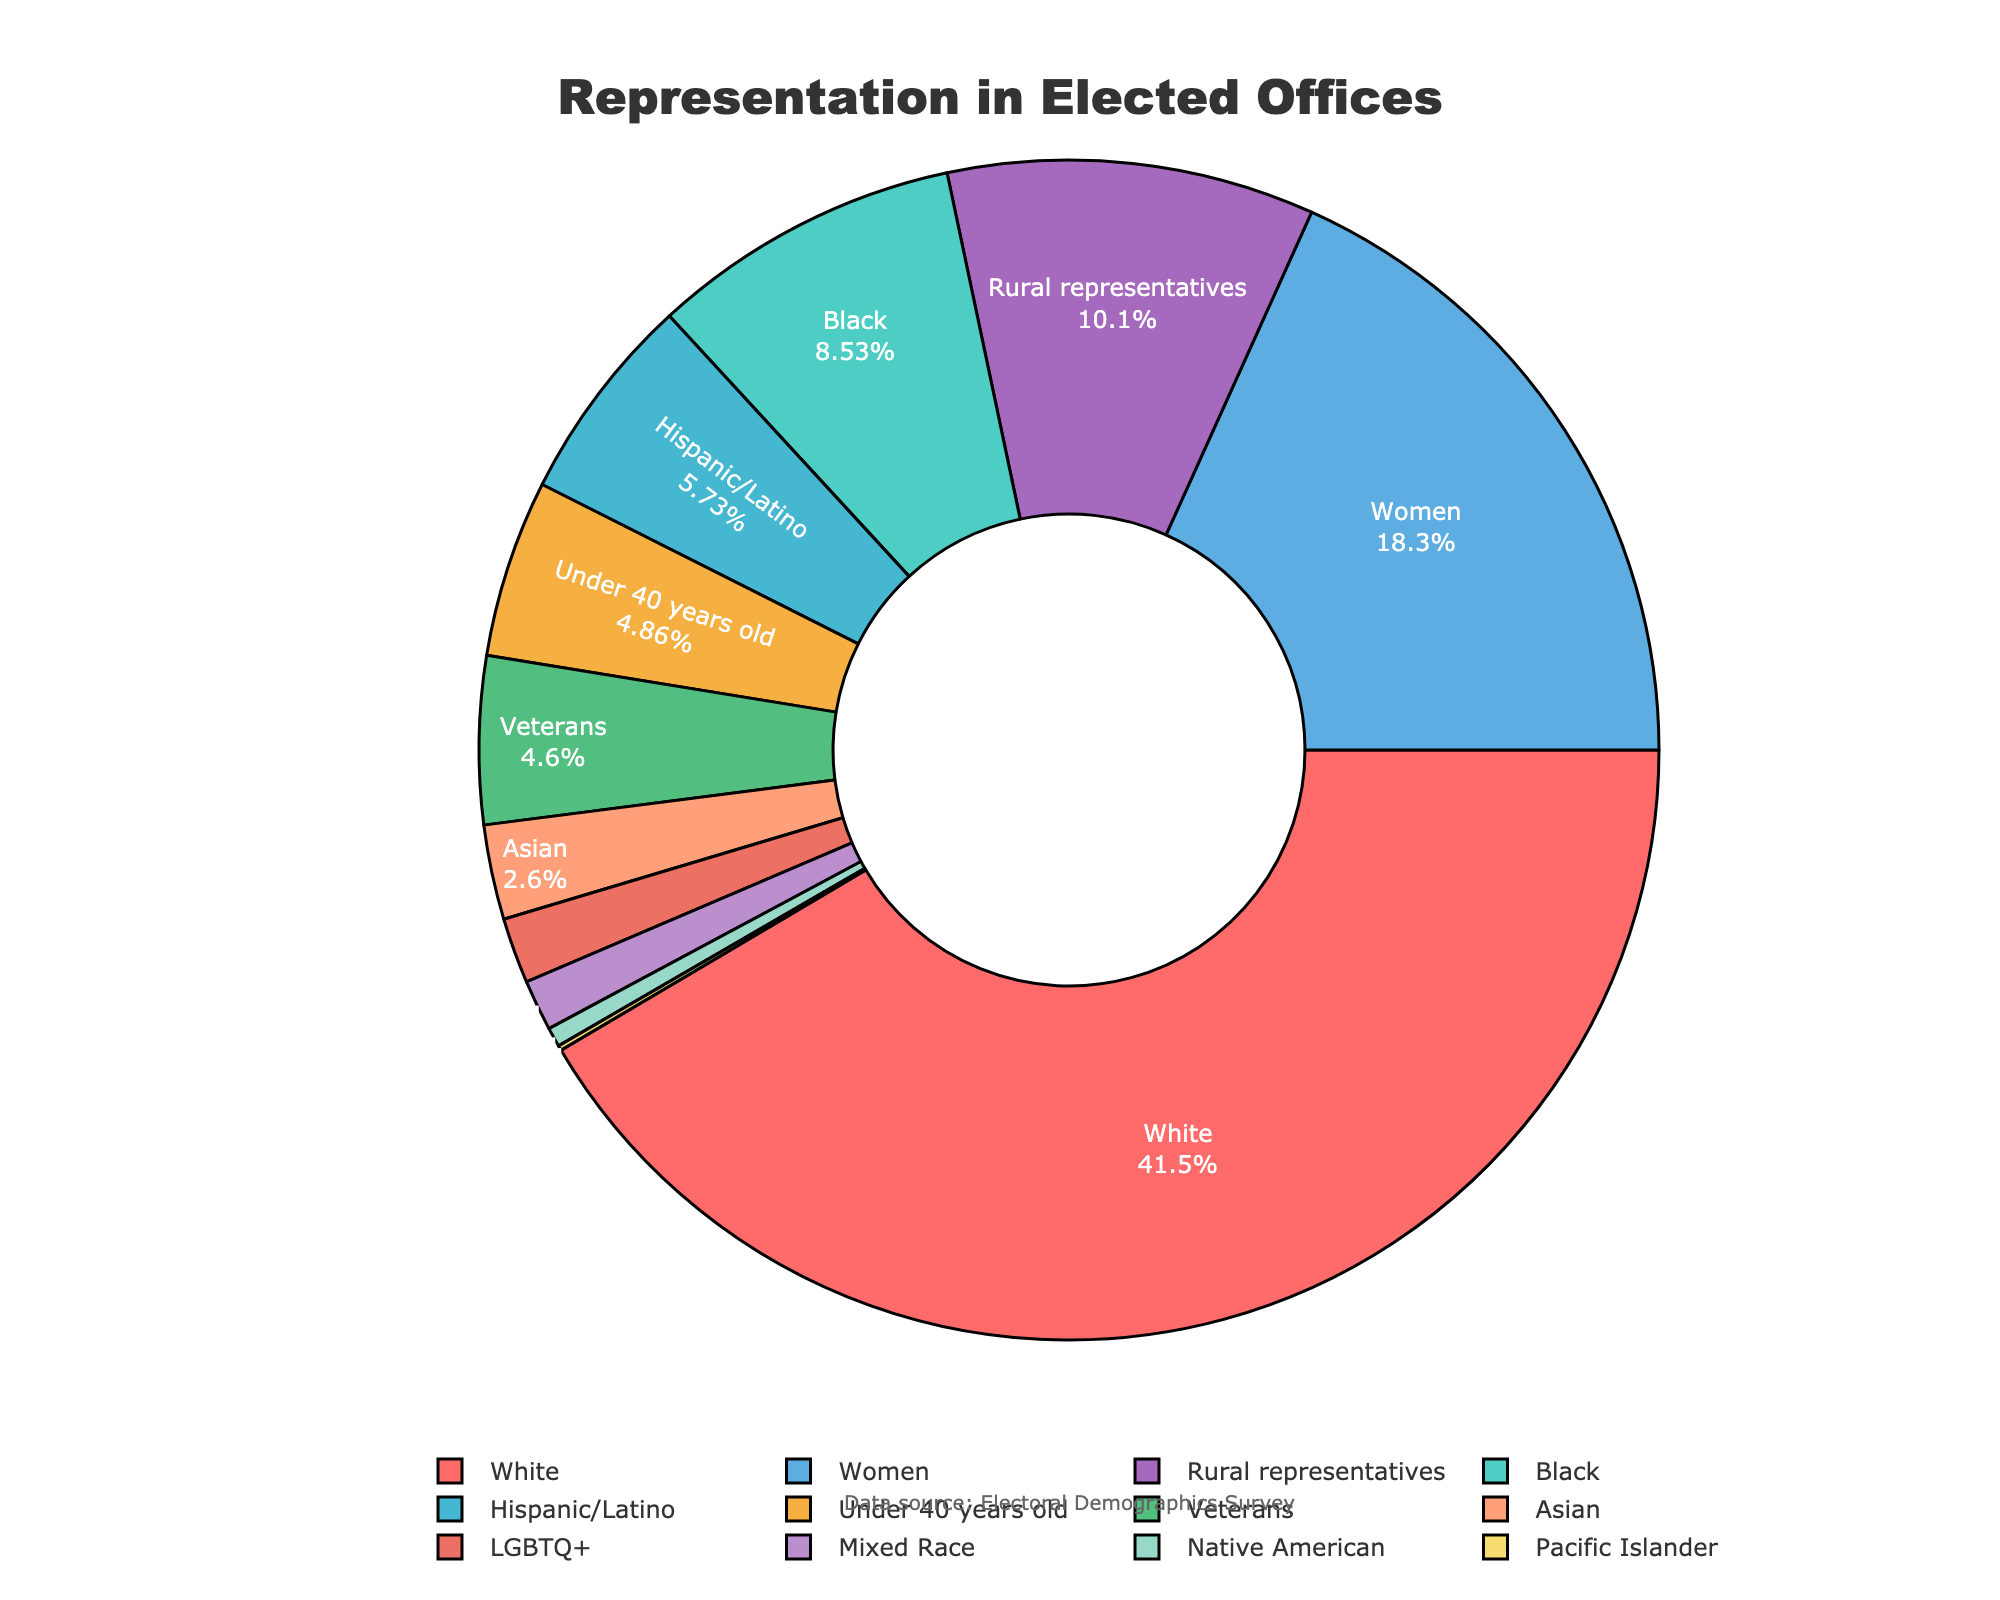What's the percentage of elected officials from the White demographic group? Look at the pie chart and identify the portion labeled "White." The chart shows that this group makes up 62.3% of the elected officials.
Answer: 62.3% How does the representation of Women compare to that of Veterans? Find the percentages for "Women" and "Veterans" in the pie chart. "Women" are at 27.4%, while "Veterans" are at 6.9%. Women have a higher representation.
Answer: Women are higher What is the combined percentage of Hispanic/Latino and Asian representatives? Locate the percentages for "Hispanic/Latino" (8.6%) and "Asian" (3.9%). Add these two values together: 8.6 + 3.9 = 12.5%.
Answer: 12.5% Which group has the smallest representation in elected offices? Look at all the slices of the pie chart and identify the smallest slice. The "Pacific Islander" group has the smallest representation with 0.2%.
Answer: Pacific Islander Are there more rural representatives than representatives under 40 years old? Compare the percentages of "Rural representatives" (15.1%) and "Under 40 years old" (7.3%). The pie chart shows that there are indeed more rural representatives.
Answer: Yes What's the total percentage of minority racial groups represented? Identify the minority racial groups: Black (12.8%), Hispanic/Latino (8.6%), Asian (3.9%), Native American (0.8%), Pacific Islander (0.2%), Mixed Race (2.1%). Add these together: 12.8 + 8.6 + 3.9 + 0.8 + 0.2 + 2.1 = 28.4%.
Answer: 28.4% Which demographics are represented below 5%? Look for slices labeled with percentages below 5%. These are: "Asian" (3.9%), "Native American" (0.8%), "Pacific Islander" (0.2%), "Mixed Race" (2.1%), and "LGBTQ+" (2.7%).
Answer: Asian, Native American, Pacific Islander, Mixed Race, LGBTQ+ What's the difference in representation between the White demographic and the next largest demographic group? Identify the percentages for "White" (62.3%) and the next largest, which is "Women" (27.4%). Subtract to find the difference: 62.3 - 27.4 = 34.9%.
Answer: 34.9% How does the representation of LGBTQ+ individuals compare to those under 40 years old? Look for the percentages of "LGBTQ+" (2.7%) and "Under 40 years old" (7.3%). Representatives under 40 years old have a higher representation.
Answer: Under 40 years old are higher What's the sum of the percentages of the smallest three demographic groups? Identify the smallest three slices: "Pacific Islander" (0.2%), "Native American" (0.8%), and "Mixed Race" (2.1%). Add these percentages: 0.2 + 0.8 + 2.1 = 3.1%.
Answer: 3.1% 